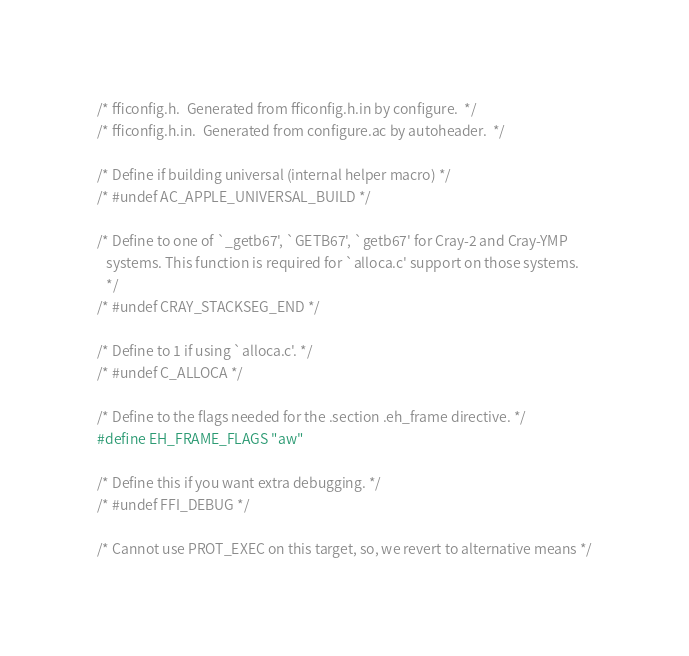<code> <loc_0><loc_0><loc_500><loc_500><_C_>/* fficonfig.h.  Generated from fficonfig.h.in by configure.  */
/* fficonfig.h.in.  Generated from configure.ac by autoheader.  */

/* Define if building universal (internal helper macro) */
/* #undef AC_APPLE_UNIVERSAL_BUILD */

/* Define to one of `_getb67', `GETB67', `getb67' for Cray-2 and Cray-YMP
   systems. This function is required for `alloca.c' support on those systems.
   */
/* #undef CRAY_STACKSEG_END */

/* Define to 1 if using `alloca.c'. */
/* #undef C_ALLOCA */

/* Define to the flags needed for the .section .eh_frame directive. */
#define EH_FRAME_FLAGS "aw"

/* Define this if you want extra debugging. */
/* #undef FFI_DEBUG */

/* Cannot use PROT_EXEC on this target, so, we revert to alternative means */</code> 